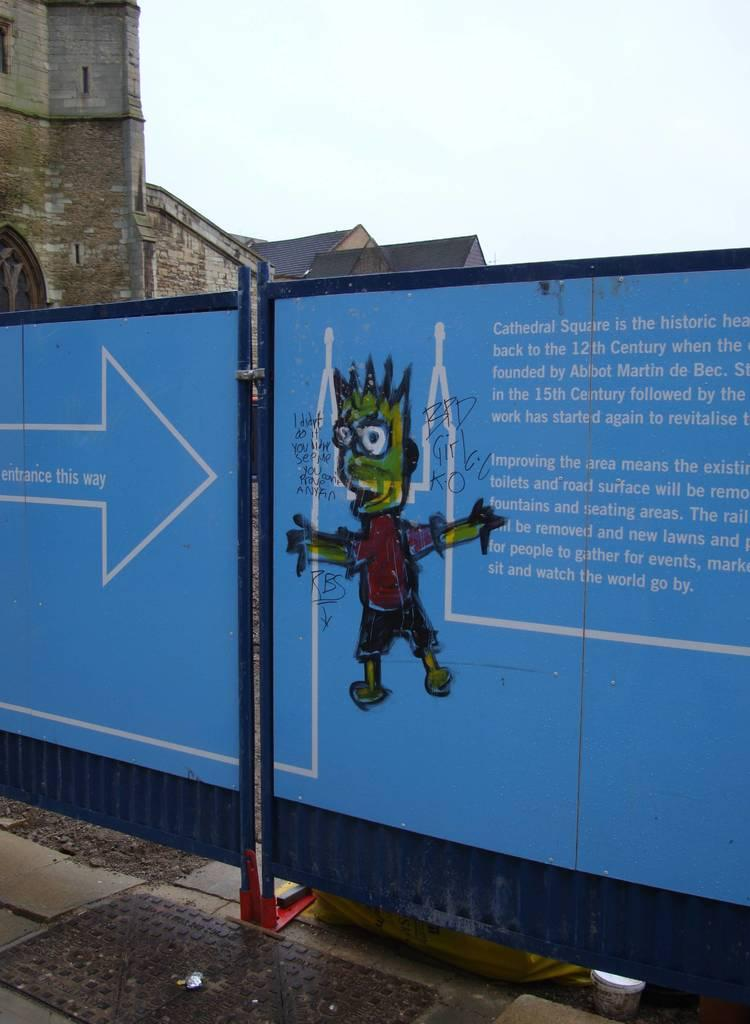What is the main object in the image? There is a board in the image. What can be seen in the top left corner of the image? There is a building in the top left of the image. What is visible at the top of the image? The sky is visible at the top of the image. How does the feather contribute to the comparison between the board and the building in the image? There is no feather present in the image, so it cannot contribute to any comparison between the board and the building. 